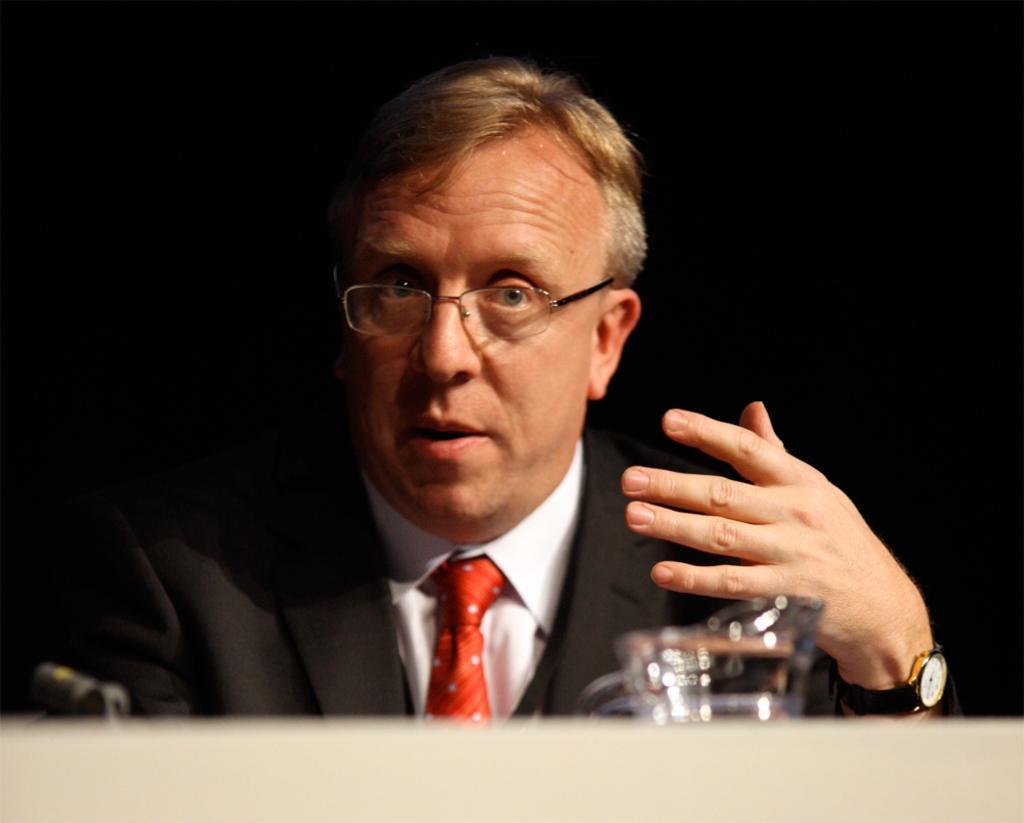Please provide a concise description of this image. In this image I can see the person and the person is wearing black blazer, white shirt and red color tie. In front I can see the microphone and a glass and I can see the dark background. 